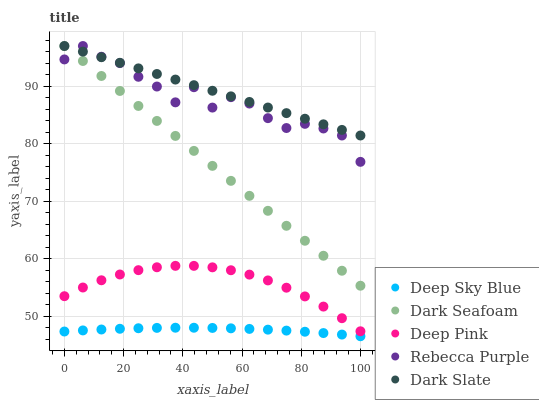Does Deep Sky Blue have the minimum area under the curve?
Answer yes or no. Yes. Does Dark Slate have the maximum area under the curve?
Answer yes or no. Yes. Does Dark Seafoam have the minimum area under the curve?
Answer yes or no. No. Does Dark Seafoam have the maximum area under the curve?
Answer yes or no. No. Is Dark Seafoam the smoothest?
Answer yes or no. Yes. Is Rebecca Purple the roughest?
Answer yes or no. Yes. Is Deep Pink the smoothest?
Answer yes or no. No. Is Deep Pink the roughest?
Answer yes or no. No. Does Deep Sky Blue have the lowest value?
Answer yes or no. Yes. Does Dark Seafoam have the lowest value?
Answer yes or no. No. Does Rebecca Purple have the highest value?
Answer yes or no. Yes. Does Deep Pink have the highest value?
Answer yes or no. No. Is Deep Sky Blue less than Dark Slate?
Answer yes or no. Yes. Is Dark Seafoam greater than Deep Pink?
Answer yes or no. Yes. Does Rebecca Purple intersect Dark Slate?
Answer yes or no. Yes. Is Rebecca Purple less than Dark Slate?
Answer yes or no. No. Is Rebecca Purple greater than Dark Slate?
Answer yes or no. No. Does Deep Sky Blue intersect Dark Slate?
Answer yes or no. No. 